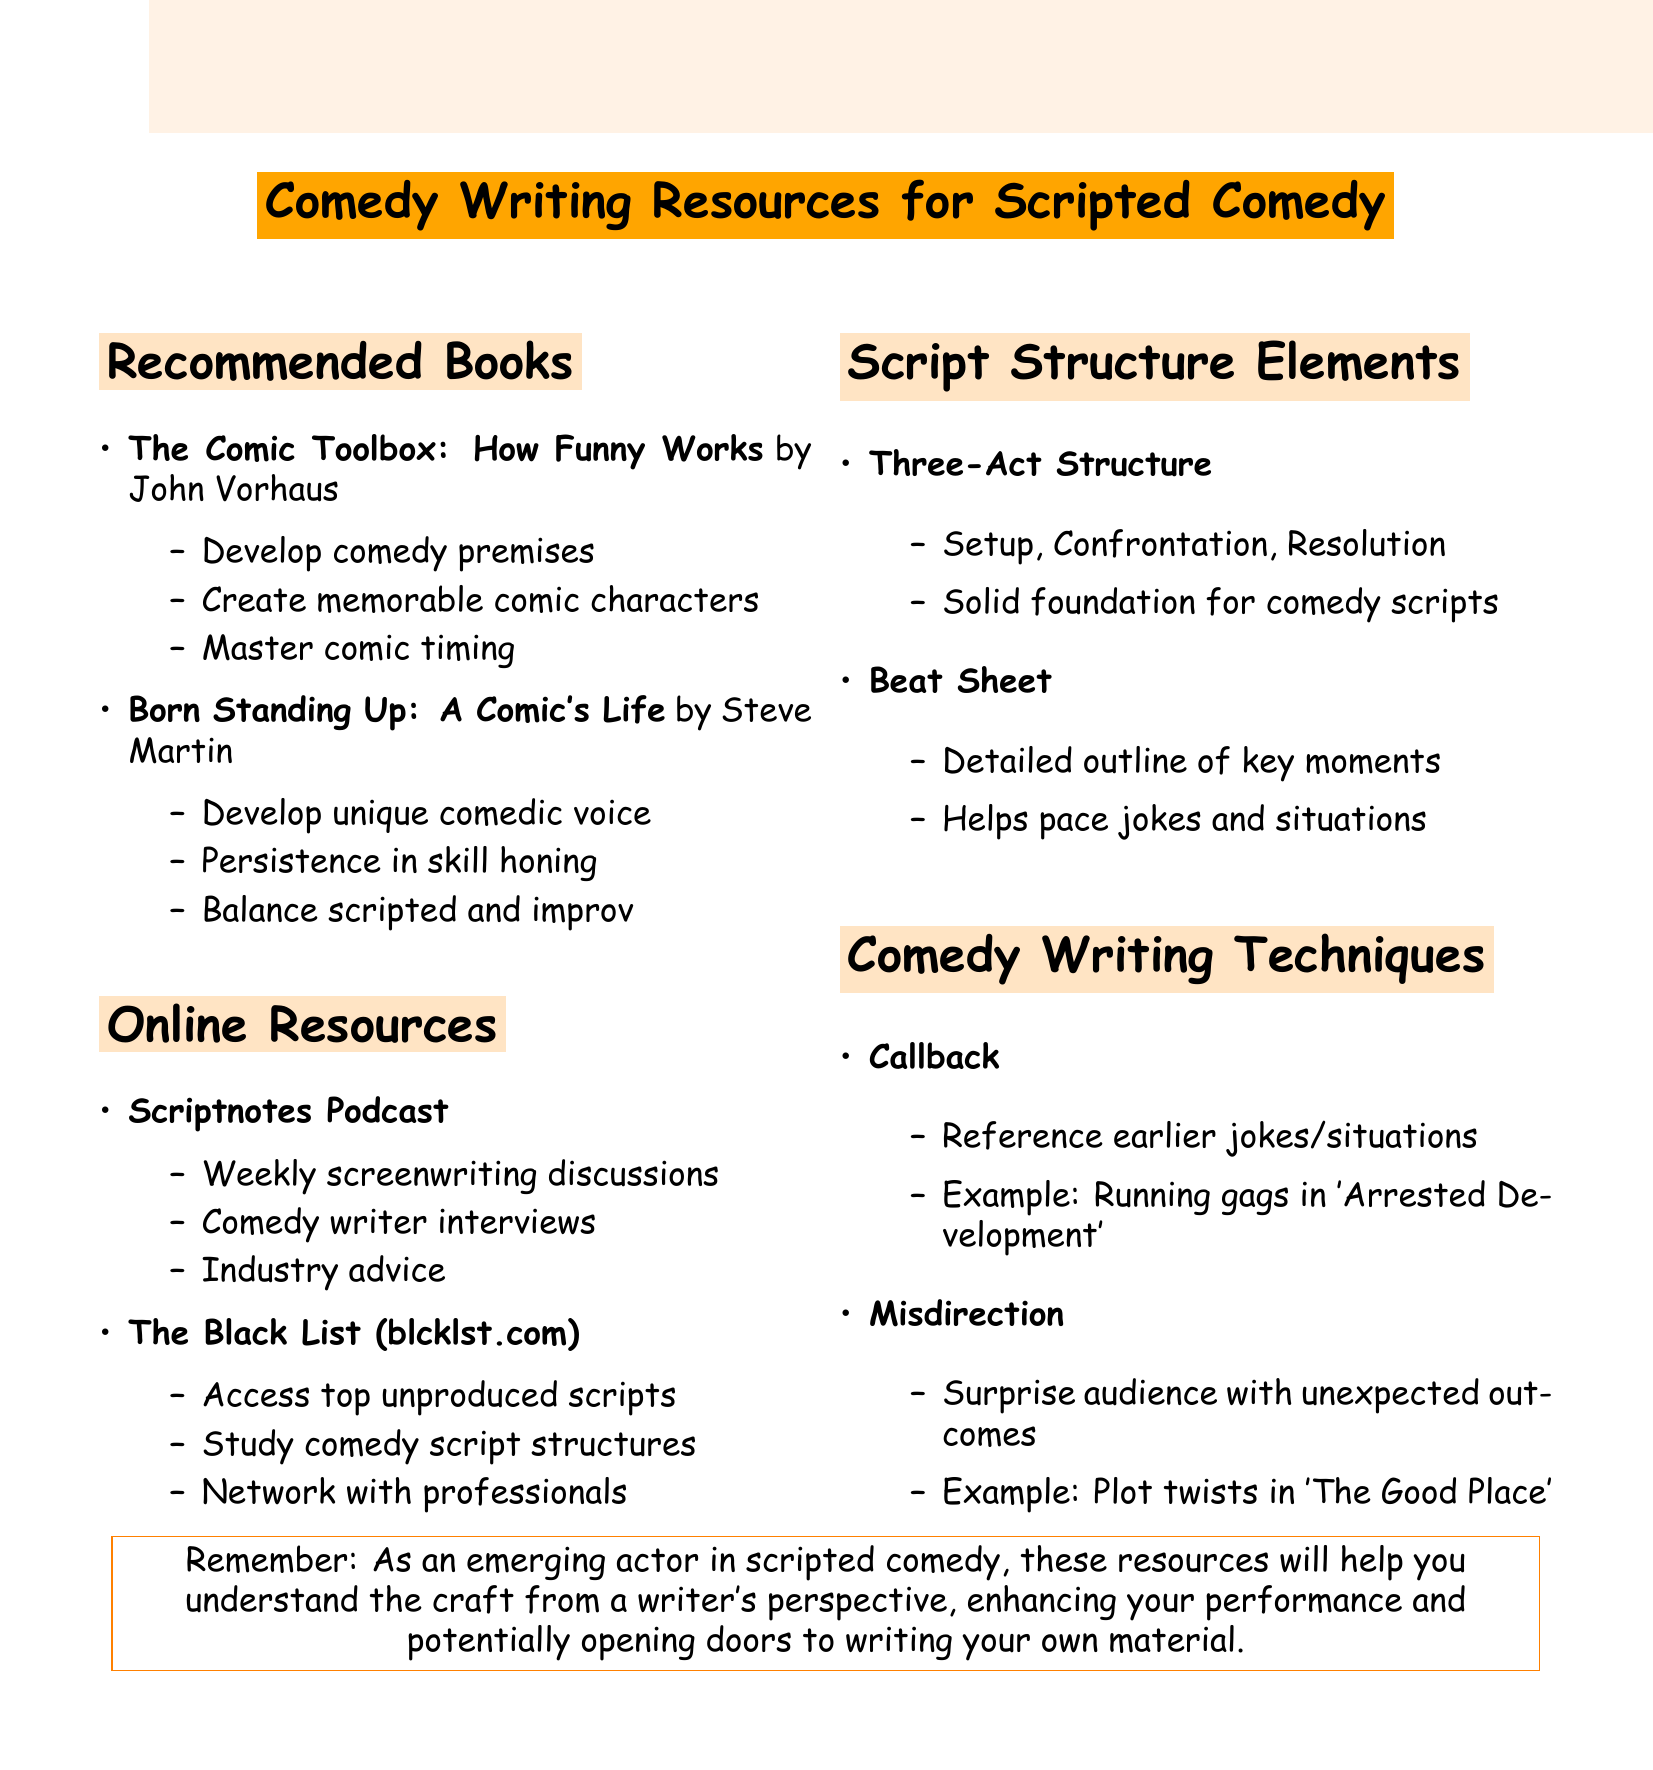What is the title of the book by John Vorhaus? The title of John Vorhaus's book is listed in the recommended books section.
Answer: The Comic Toolbox: How Funny Works What is one key takeaway from "Born Standing Up: A Comic's Life"? Key takeaways from the book by Steve Martin are provided in the notes.
Answer: The value of persistence in honing comedic skills Who are the hosts of the Scriptnotes Podcast? The hosts of the Scriptnotes Podcast are mentioned under online resources.
Answer: John August and Craig Mazin What element of script structure is described as providing a solid foundation? The importance of elements related to script structure is given in the document.
Answer: Three-Act Structure Which technique involves referencing earlier jokes? The comedy writing techniques section details various techniques, including one mentioned in the question.
Answer: Callback What online resource provides access to unproduced scripts? The online resources listed include The Black List, which provides specific benefits.
Answer: The Black List What is the purpose of a Beat Sheet in comedy scripts? The description of the Beat Sheet can be found in the elements of script structure.
Answer: Helps in pacing jokes and comedic situations throughout the script What is a practical benefit of The Black List? Benefits of The Black List are outlined in the online resources section.
Answer: Networking with other emerging writers and industry professionals 